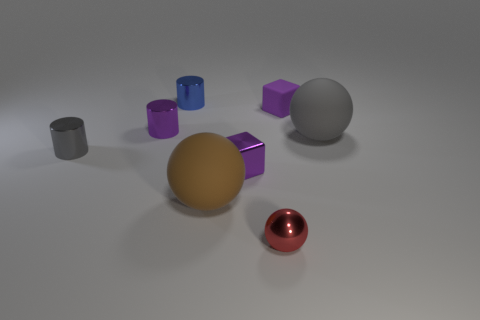Subtract all large balls. How many balls are left? 1 Subtract 1 balls. How many balls are left? 2 Add 2 large blue metallic cylinders. How many objects exist? 10 Subtract all cylinders. How many objects are left? 5 Add 6 large brown metal spheres. How many large brown metal spheres exist? 6 Subtract 1 gray cylinders. How many objects are left? 7 Subtract all purple balls. Subtract all purple cubes. How many balls are left? 3 Subtract all large metallic spheres. Subtract all tiny red spheres. How many objects are left? 7 Add 3 brown matte spheres. How many brown matte spheres are left? 4 